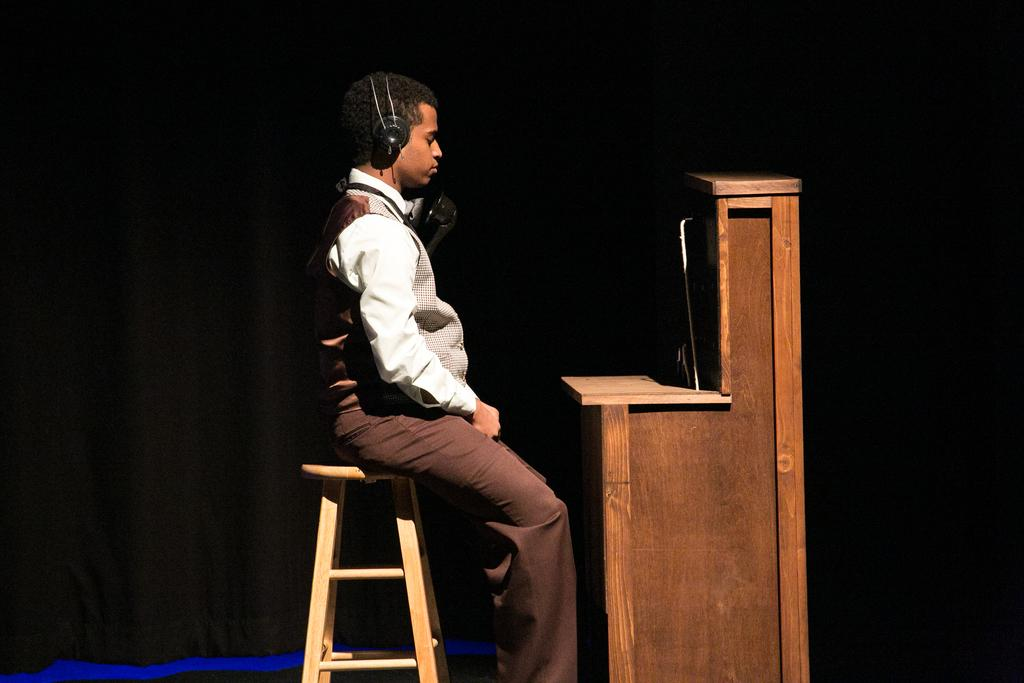What is the man in the image doing? The man is sitting on a chair in the image. What can be seen on the man's head? The man is wearing a wired headset. What is in front of the man? There is a table in front of the man. How would you describe the lighting in the image? The background of the image is dark. What type of boats can be seen in the harbor in the image? There is no harbor or boats present in the image; it features a man sitting on a chair with a wired headset and a table in front of him. How many pizzas are on the table in the image? There is no pizza visible in the image; it only shows a man sitting on a chair with a wired headset and a table in front of him. 